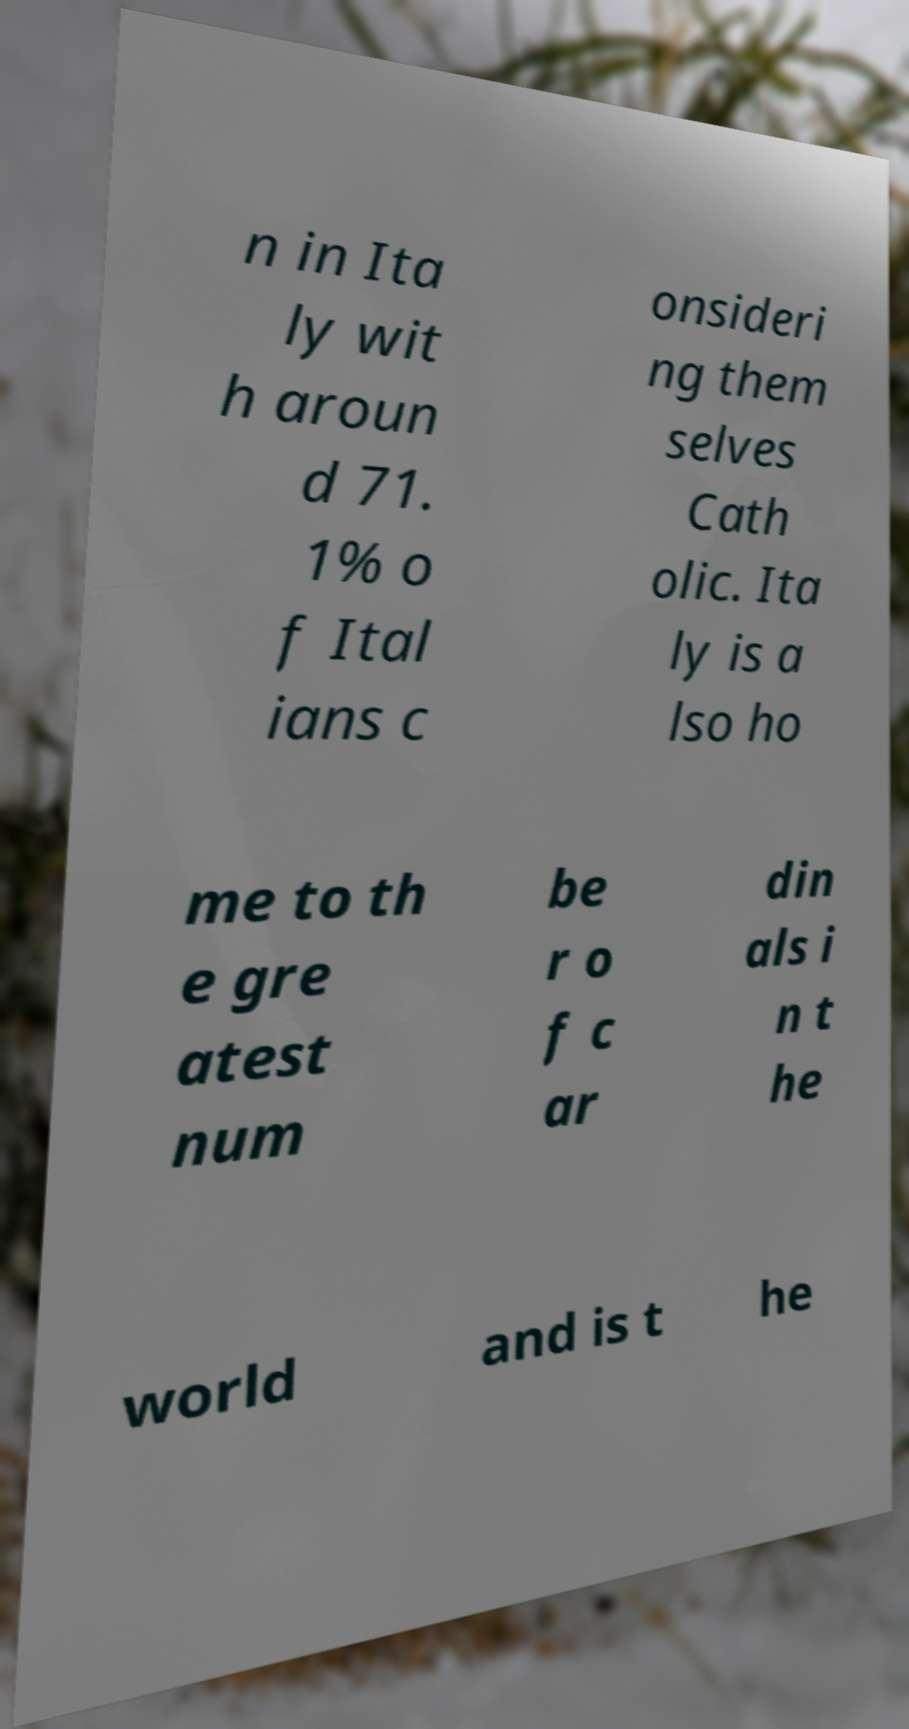I need the written content from this picture converted into text. Can you do that? n in Ita ly wit h aroun d 71. 1% o f Ital ians c onsideri ng them selves Cath olic. Ita ly is a lso ho me to th e gre atest num be r o f c ar din als i n t he world and is t he 